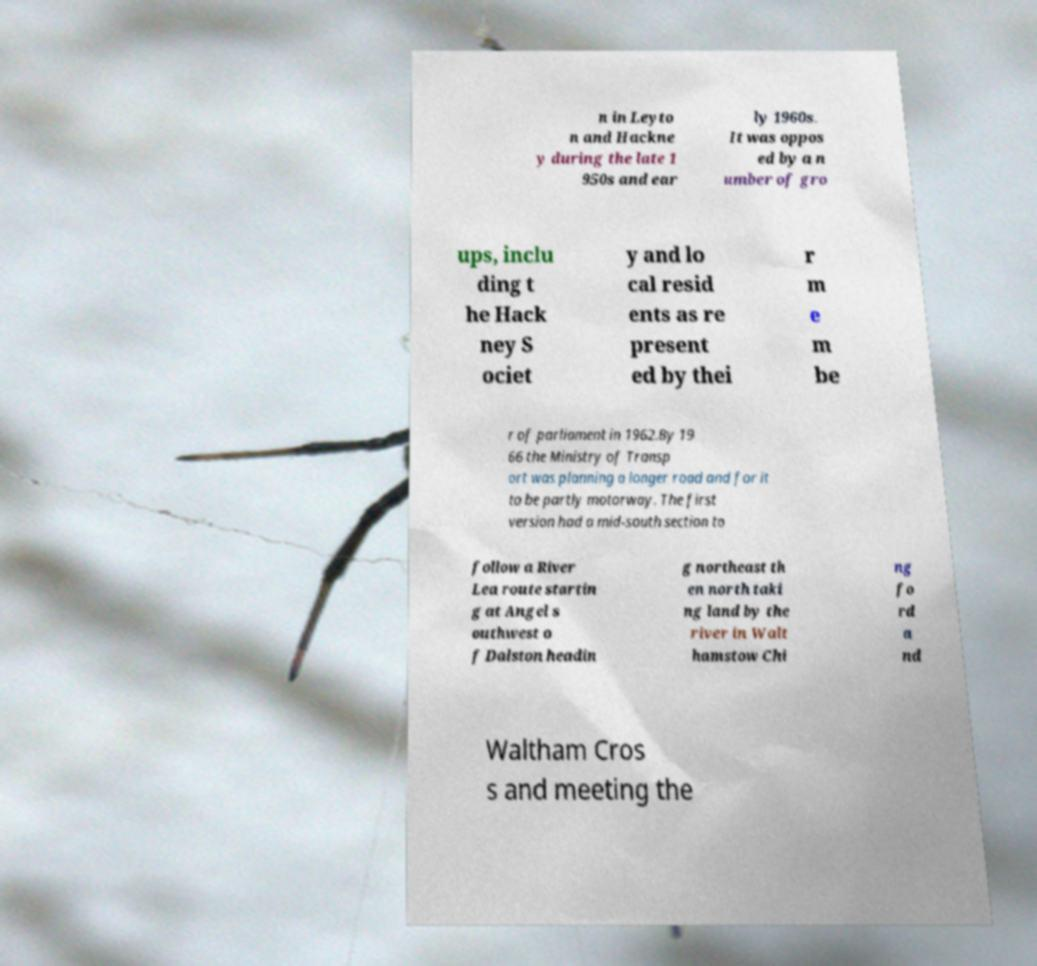I need the written content from this picture converted into text. Can you do that? n in Leyto n and Hackne y during the late 1 950s and ear ly 1960s. It was oppos ed by a n umber of gro ups, inclu ding t he Hack ney S ociet y and lo cal resid ents as re present ed by thei r m e m be r of parliament in 1962.By 19 66 the Ministry of Transp ort was planning a longer road and for it to be partly motorway. The first version had a mid-south section to follow a River Lea route startin g at Angel s outhwest o f Dalston headin g northeast th en north taki ng land by the river in Walt hamstow Chi ng fo rd a nd Waltham Cros s and meeting the 